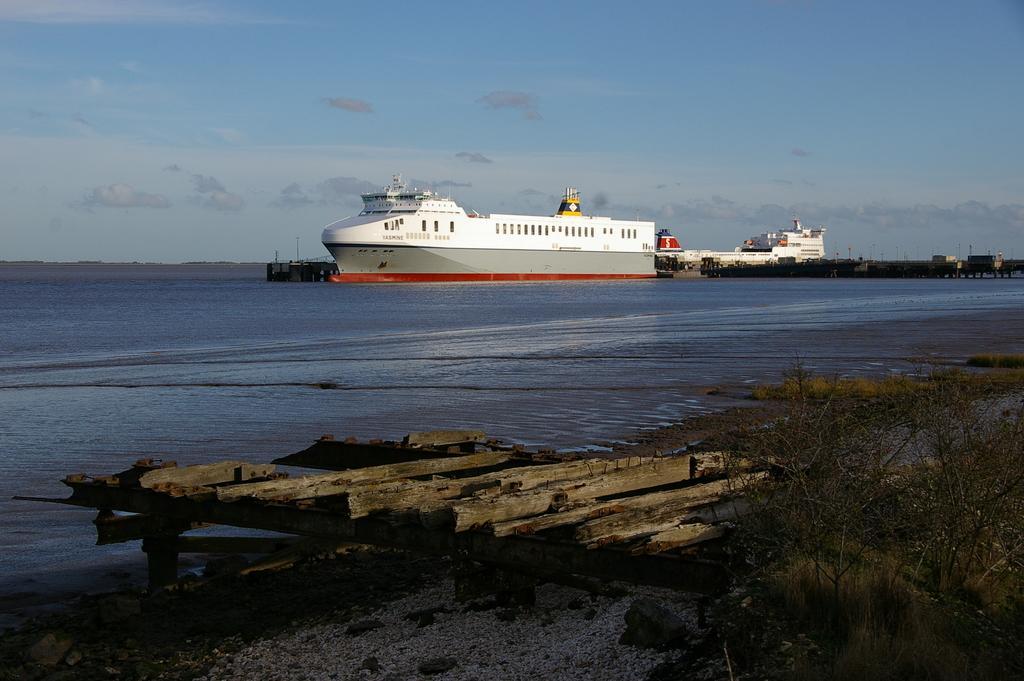Can you describe this image briefly? In this image in the middle, there are boats. At the bottom there are plants, wooden sticks, water. At the top there is sky and clouds. 